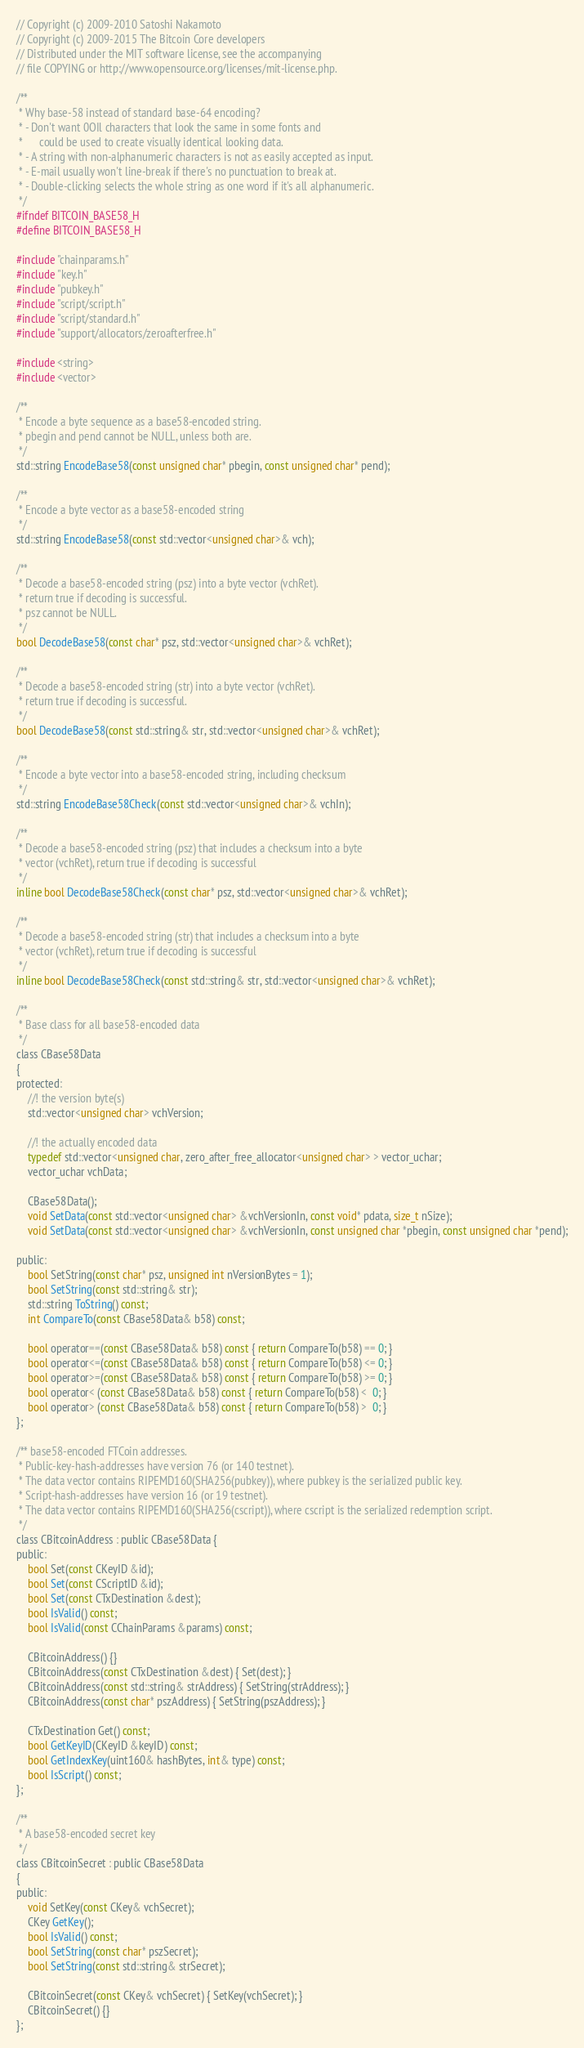<code> <loc_0><loc_0><loc_500><loc_500><_C_>// Copyright (c) 2009-2010 Satoshi Nakamoto
// Copyright (c) 2009-2015 The Bitcoin Core developers
// Distributed under the MIT software license, see the accompanying
// file COPYING or http://www.opensource.org/licenses/mit-license.php.

/**
 * Why base-58 instead of standard base-64 encoding?
 * - Don't want 0OIl characters that look the same in some fonts and
 *      could be used to create visually identical looking data.
 * - A string with non-alphanumeric characters is not as easily accepted as input.
 * - E-mail usually won't line-break if there's no punctuation to break at.
 * - Double-clicking selects the whole string as one word if it's all alphanumeric.
 */
#ifndef BITCOIN_BASE58_H
#define BITCOIN_BASE58_H

#include "chainparams.h"
#include "key.h"
#include "pubkey.h"
#include "script/script.h"
#include "script/standard.h"
#include "support/allocators/zeroafterfree.h"

#include <string>
#include <vector>

/**
 * Encode a byte sequence as a base58-encoded string.
 * pbegin and pend cannot be NULL, unless both are.
 */
std::string EncodeBase58(const unsigned char* pbegin, const unsigned char* pend);

/**
 * Encode a byte vector as a base58-encoded string
 */
std::string EncodeBase58(const std::vector<unsigned char>& vch);

/**
 * Decode a base58-encoded string (psz) into a byte vector (vchRet).
 * return true if decoding is successful.
 * psz cannot be NULL.
 */
bool DecodeBase58(const char* psz, std::vector<unsigned char>& vchRet);

/**
 * Decode a base58-encoded string (str) into a byte vector (vchRet).
 * return true if decoding is successful.
 */
bool DecodeBase58(const std::string& str, std::vector<unsigned char>& vchRet);

/**
 * Encode a byte vector into a base58-encoded string, including checksum
 */
std::string EncodeBase58Check(const std::vector<unsigned char>& vchIn);

/**
 * Decode a base58-encoded string (psz) that includes a checksum into a byte
 * vector (vchRet), return true if decoding is successful
 */
inline bool DecodeBase58Check(const char* psz, std::vector<unsigned char>& vchRet);

/**
 * Decode a base58-encoded string (str) that includes a checksum into a byte
 * vector (vchRet), return true if decoding is successful
 */
inline bool DecodeBase58Check(const std::string& str, std::vector<unsigned char>& vchRet);

/**
 * Base class for all base58-encoded data
 */
class CBase58Data
{
protected:
    //! the version byte(s)
    std::vector<unsigned char> vchVersion;

    //! the actually encoded data
    typedef std::vector<unsigned char, zero_after_free_allocator<unsigned char> > vector_uchar;
    vector_uchar vchData;

    CBase58Data();
    void SetData(const std::vector<unsigned char> &vchVersionIn, const void* pdata, size_t nSize);
    void SetData(const std::vector<unsigned char> &vchVersionIn, const unsigned char *pbegin, const unsigned char *pend);

public:
    bool SetString(const char* psz, unsigned int nVersionBytes = 1);
    bool SetString(const std::string& str);
    std::string ToString() const;
    int CompareTo(const CBase58Data& b58) const;

    bool operator==(const CBase58Data& b58) const { return CompareTo(b58) == 0; }
    bool operator<=(const CBase58Data& b58) const { return CompareTo(b58) <= 0; }
    bool operator>=(const CBase58Data& b58) const { return CompareTo(b58) >= 0; }
    bool operator< (const CBase58Data& b58) const { return CompareTo(b58) <  0; }
    bool operator> (const CBase58Data& b58) const { return CompareTo(b58) >  0; }
};

/** base58-encoded FTCoin addresses.
 * Public-key-hash-addresses have version 76 (or 140 testnet).
 * The data vector contains RIPEMD160(SHA256(pubkey)), where pubkey is the serialized public key.
 * Script-hash-addresses have version 16 (or 19 testnet).
 * The data vector contains RIPEMD160(SHA256(cscript)), where cscript is the serialized redemption script.
 */
class CBitcoinAddress : public CBase58Data {
public:
    bool Set(const CKeyID &id);
    bool Set(const CScriptID &id);
    bool Set(const CTxDestination &dest);
    bool IsValid() const;
    bool IsValid(const CChainParams &params) const;

    CBitcoinAddress() {}
    CBitcoinAddress(const CTxDestination &dest) { Set(dest); }
    CBitcoinAddress(const std::string& strAddress) { SetString(strAddress); }
    CBitcoinAddress(const char* pszAddress) { SetString(pszAddress); }

    CTxDestination Get() const;
    bool GetKeyID(CKeyID &keyID) const;
    bool GetIndexKey(uint160& hashBytes, int& type) const;
    bool IsScript() const;
};

/**
 * A base58-encoded secret key
 */
class CBitcoinSecret : public CBase58Data
{
public:
    void SetKey(const CKey& vchSecret);
    CKey GetKey();
    bool IsValid() const;
    bool SetString(const char* pszSecret);
    bool SetString(const std::string& strSecret);

    CBitcoinSecret(const CKey& vchSecret) { SetKey(vchSecret); }
    CBitcoinSecret() {}
};
</code> 